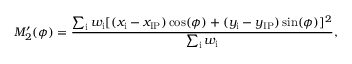Convert formula to latex. <formula><loc_0><loc_0><loc_500><loc_500>M _ { 2 } ^ { \prime } ( \phi ) = \frac { \sum _ { i } w _ { i } [ ( x _ { i } - x _ { I P } ) \cos ( \phi ) + ( y _ { i } - y _ { I P } ) \sin ( \phi ) ] ^ { 2 } } { \sum _ { i } w _ { i } } ,</formula> 